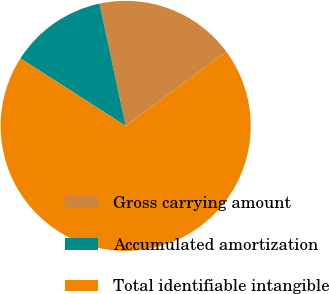<chart> <loc_0><loc_0><loc_500><loc_500><pie_chart><fcel>Gross carrying amount<fcel>Accumulated amortization<fcel>Total identifiable intangible<nl><fcel>18.23%<fcel>12.56%<fcel>69.21%<nl></chart> 